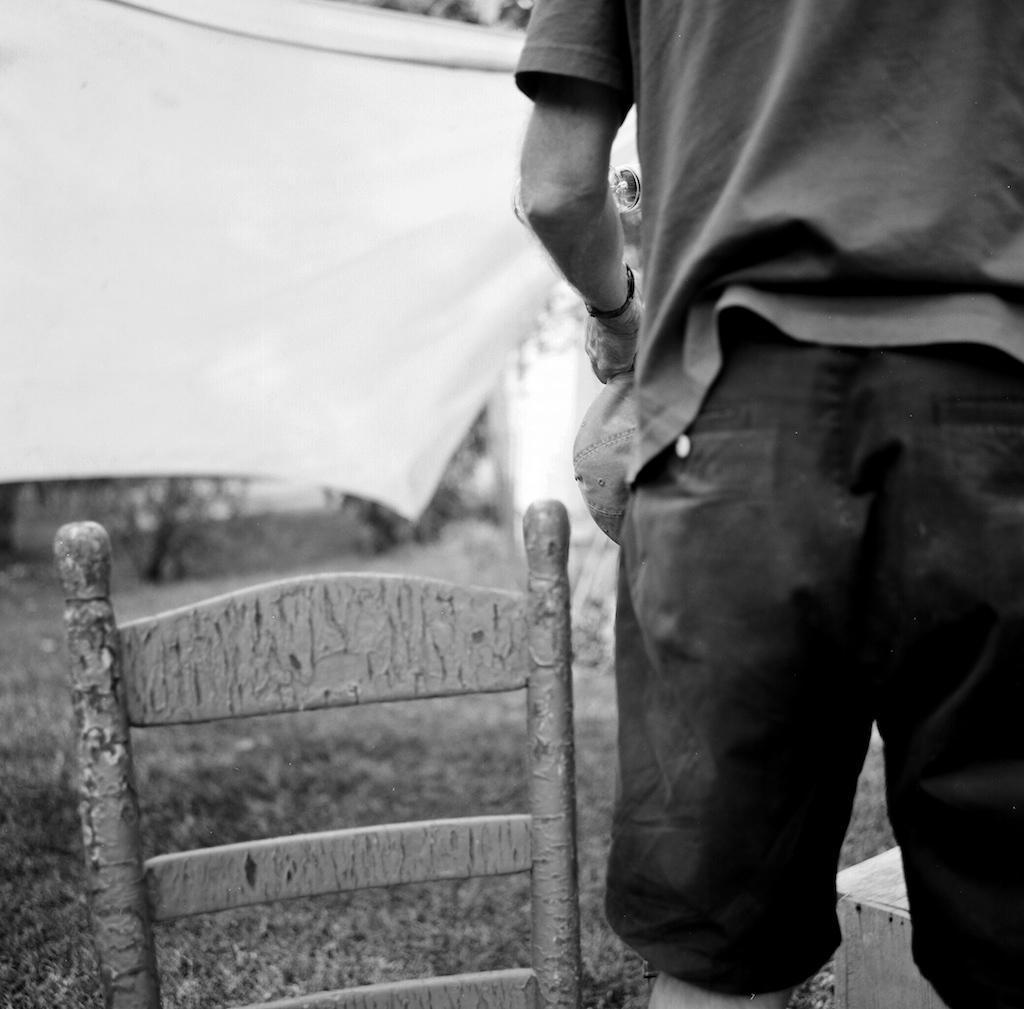Could you give a brief overview of what you see in this image? In the right bottom, we see a wooden block. Beside that, we see a man is standing and he is holding a cap. Beside him, we see a chair. On the left side, we see a cloth or a banner in white color. At the bottom, we see the grass. There are trees in the background. We even see a white wall. This picture is in black and white. 